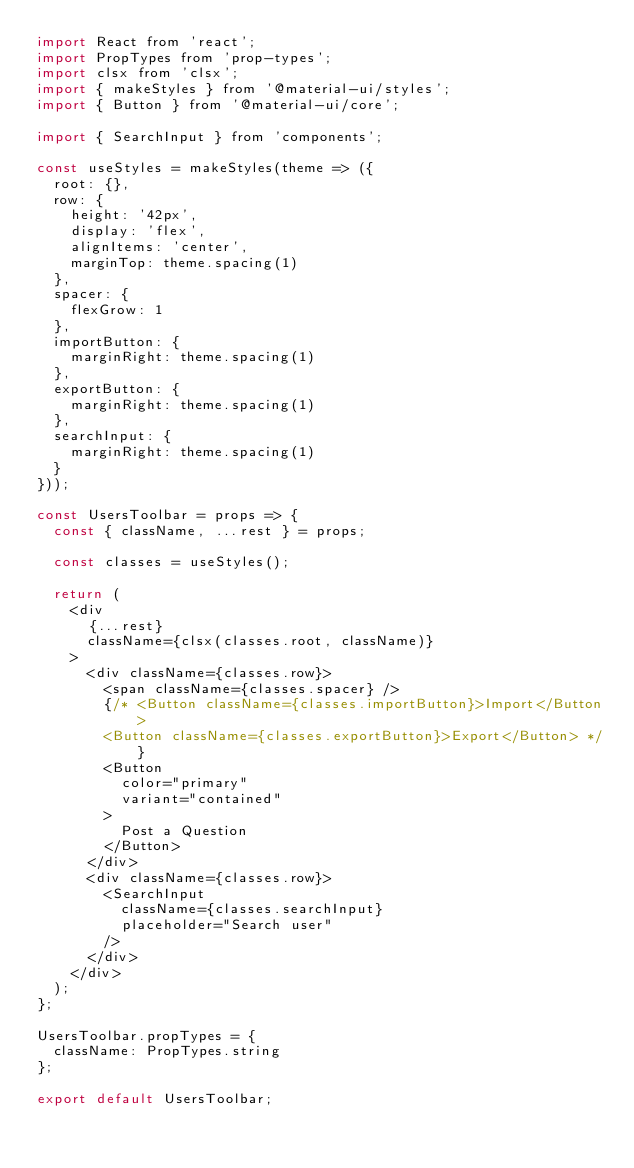<code> <loc_0><loc_0><loc_500><loc_500><_JavaScript_>import React from 'react';
import PropTypes from 'prop-types';
import clsx from 'clsx';
import { makeStyles } from '@material-ui/styles';
import { Button } from '@material-ui/core';

import { SearchInput } from 'components';

const useStyles = makeStyles(theme => ({
  root: {},
  row: {
    height: '42px',
    display: 'flex',
    alignItems: 'center',
    marginTop: theme.spacing(1)
  },
  spacer: {
    flexGrow: 1
  },
  importButton: {
    marginRight: theme.spacing(1)
  },
  exportButton: {
    marginRight: theme.spacing(1)
  },
  searchInput: {
    marginRight: theme.spacing(1)
  }
}));

const UsersToolbar = props => {
  const { className, ...rest } = props;

  const classes = useStyles();

  return (
    <div
      {...rest}
      className={clsx(classes.root, className)}
    >
      <div className={classes.row}>
        <span className={classes.spacer} />
        {/* <Button className={classes.importButton}>Import</Button>
        <Button className={classes.exportButton}>Export</Button> */}
        <Button
          color="primary"
          variant="contained"
        >
          Post a Question
        </Button>
      </div>
      <div className={classes.row}>
        <SearchInput
          className={classes.searchInput}
          placeholder="Search user"
        />
      </div>
    </div>
  );
};

UsersToolbar.propTypes = {
  className: PropTypes.string
};

export default UsersToolbar;
</code> 